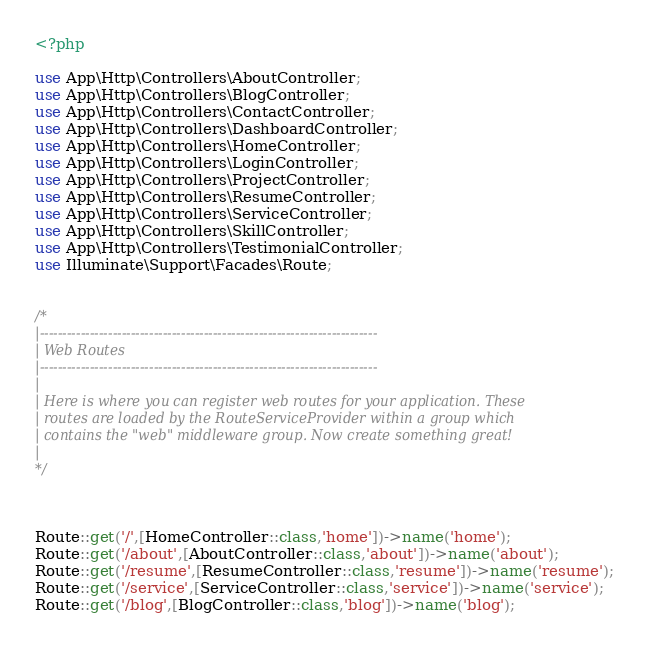Convert code to text. <code><loc_0><loc_0><loc_500><loc_500><_PHP_><?php

use App\Http\Controllers\AboutController;
use App\Http\Controllers\BlogController;
use App\Http\Controllers\ContactController;
use App\Http\Controllers\DashboardController;
use App\Http\Controllers\HomeController;
use App\Http\Controllers\LoginController;
use App\Http\Controllers\ProjectController;
use App\Http\Controllers\ResumeController;
use App\Http\Controllers\ServiceController;
use App\Http\Controllers\SkillController;
use App\Http\Controllers\TestimonialController;
use Illuminate\Support\Facades\Route;


/*
|--------------------------------------------------------------------------
| Web Routes
|--------------------------------------------------------------------------
|
| Here is where you can register web routes for your application. These
| routes are loaded by the RouteServiceProvider within a group which
| contains the "web" middleware group. Now create something great!
|
*/



Route::get('/',[HomeController::class,'home'])->name('home');
Route::get('/about',[AboutController::class,'about'])->name('about');
Route::get('/resume',[ResumeController::class,'resume'])->name('resume');
Route::get('/service',[ServiceController::class,'service'])->name('service');
Route::get('/blog',[BlogController::class,'blog'])->name('blog');</code> 